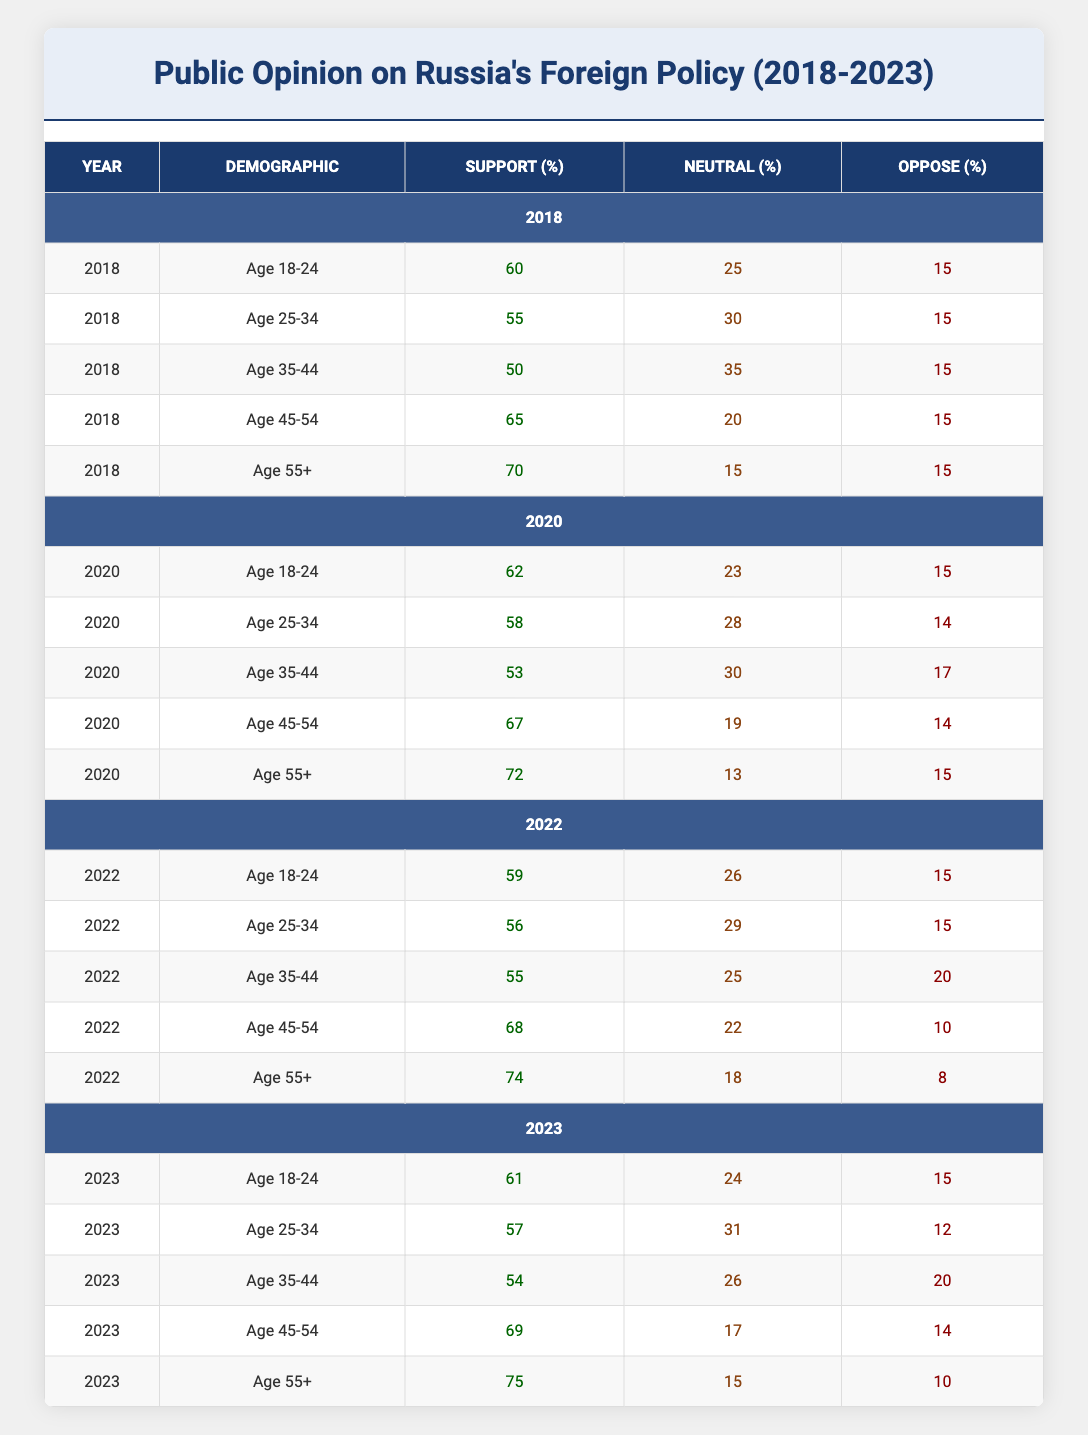What was the support percentage for the demographic aged 35-44 in 2020? The specific row for the demographic aged 35-44 in the year 2020 shows a support percentage of 53.
Answer: 53 Which demographic had the highest support percentage for foreign policy decisions in 2022? The demographic aged 55+ had the highest support percentage of 74 in 2022, compared to the other age groups.
Answer: Age 55+ What is the difference in support percentage between the age group 25-34 in 2018 and 2023? The support percentage for age 25-34 in 2018 is 55, and in 2023 it is 57. The difference is 57 - 55 = 2.
Answer: 2 Was there any demographic in 2020 where the opposition percentage dropped compared to 2018? Analyzing the demographics, for the age group 25-34, the opposition percentage dropped from 15 in 2018 to 14 in 2020. Therefore, yes, there was a demographic with a decrease in opposition.
Answer: Yes In which year did the overall support percentage for the demographic aged 18-24 decline compared to the previous year? Comparing the years, in 2022, the support percentage for the demographic aged 18-24 dropped from 62 in 2020 to 59. Thus, the support declined in 2022 compared to 2020.
Answer: 2022 What is the average support percentage for the demographic aged 45-54 across the years from 2018 to 2023? Calculating the average for age 45-54: (65 + 67 + 68 + 69) / 4 = 67.25. Therefore, the average support percentage is approximately 67.25.
Answer: 67.25 Which age group consistently had the highest neutral percentage across all years provided in the table? Age group 35-44 showed the highest neutral percentages in all years: 35% in 2018, 30% in 2020, 25% in 2022, and 26% in 2023.
Answer: Age 35-44 Across the years, did the opposition percentage for ages 55+ decrease by more than 5 percent from 2018 to 2023? The opposition percentages were 15% in 2018 and 10% in 2023. Thus, the decrease is 15 - 10 = 5%, which is not more than 5%. Therefore, the answer is no.
Answer: No 